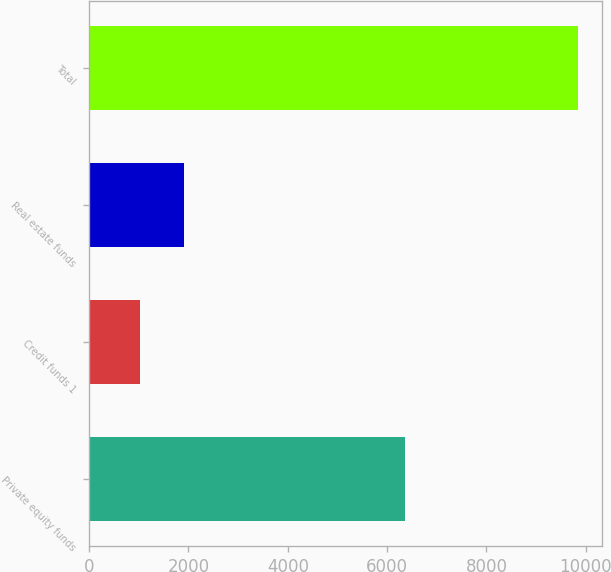Convert chart to OTSL. <chart><loc_0><loc_0><loc_500><loc_500><bar_chart><fcel>Private equity funds<fcel>Credit funds 1<fcel>Real estate funds<fcel>Total<nl><fcel>6356<fcel>1021<fcel>1903.3<fcel>9844<nl></chart> 